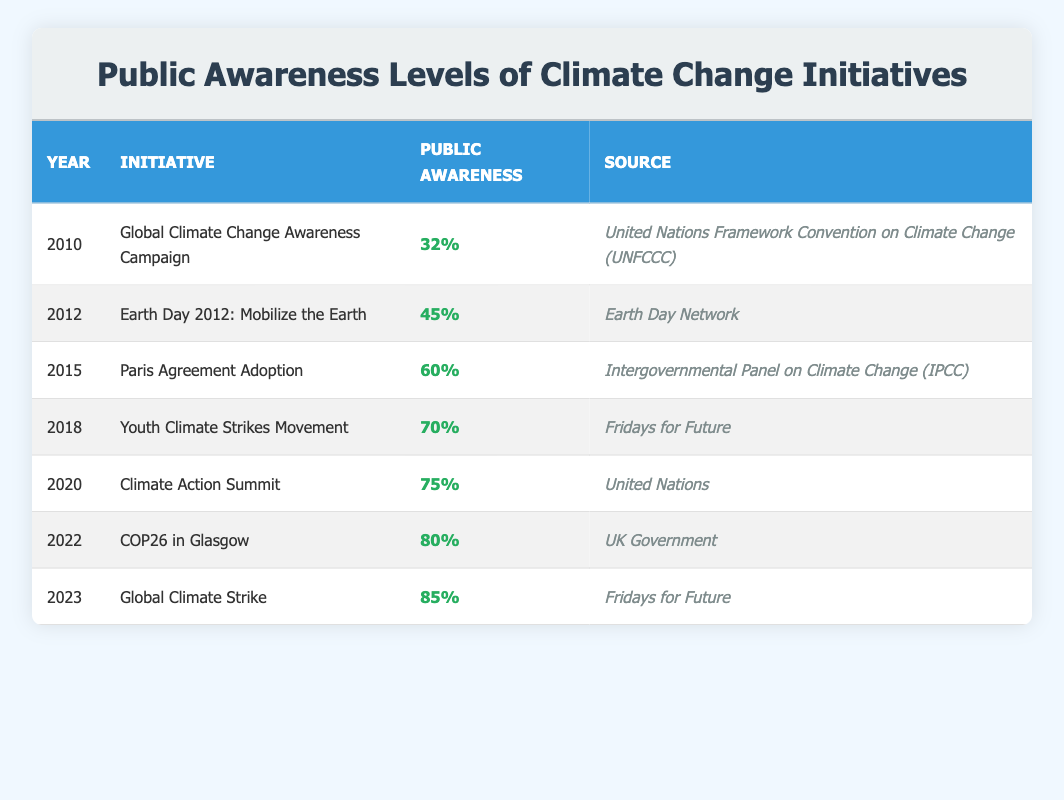What was the public awareness percentage in 2010? The table states that the year 2010 has a public awareness percentage of 32% for the "Global Climate Change Awareness Campaign."
Answer: 32% In which year did the public awareness first exceed 60%? The table shows that in 2015, with the "Paris Agreement Adoption," the public awareness percentage reached 60%. The following year, 2018, saw it exceed 60% with a percentage of 70%. Therefore, the first year exceeding 60% is 2018.
Answer: 2018 What are the sources for the public awareness initiatives in 2018 and 2022? The source for the "Youth Climate Strikes Movement" in 2018 is "Fridays for Future," and for "COP26 in Glasgow" in 2022, the source is "UK Government."
Answer: Fridays for Future and UK Government What is the average public awareness percentage from 2010 to 2023? The public awareness percentages for the years from 2010 to 2023 are 32, 45, 60, 70, 75, 80, and 85. To find the average, sum these values: 32 + 45 + 60 + 70 + 75 + 80 + 85 = 447. There are 7 values, so the average is 447 / 7 = 63.86.
Answer: 63.86 Has public awareness increased every year from 2010 to 2023? By comparing the public awareness percentages year by year in the table, we see an increase each year: 32, 45, 60, 70, 75, 80, and 85. Therefore, the statement is true.
Answer: Yes What was the difference in public awareness percentage between the initiatives of 2015 and 2023? The public awareness in 2015 for the "Paris Agreement Adoption" was 60%, while in 2023 for the "Global Climate Strike," it was 85%. The difference is calculated as 85 - 60, which equals 25.
Answer: 25 